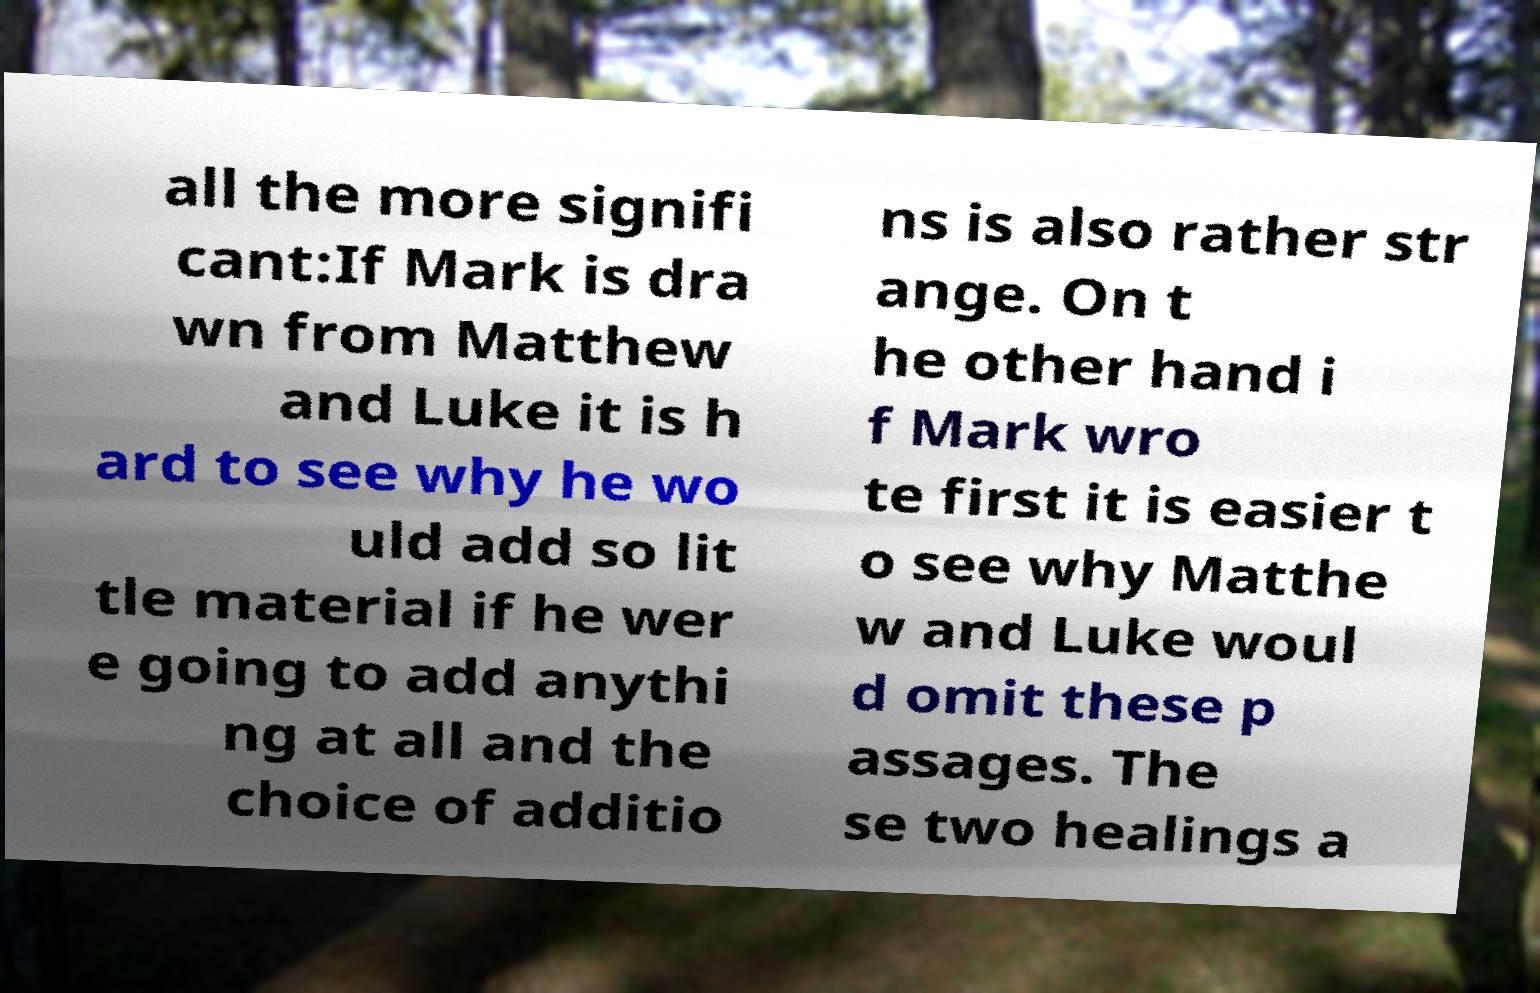Could you extract and type out the text from this image? all the more signifi cant:If Mark is dra wn from Matthew and Luke it is h ard to see why he wo uld add so lit tle material if he wer e going to add anythi ng at all and the choice of additio ns is also rather str ange. On t he other hand i f Mark wro te first it is easier t o see why Matthe w and Luke woul d omit these p assages. The se two healings a 